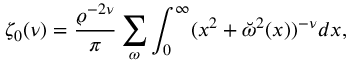<formula> <loc_0><loc_0><loc_500><loc_500>\zeta _ { 0 } ( \nu ) = { \frac { \varrho ^ { - 2 \nu } } { \pi } } \sum _ { \omega } \int _ { 0 } ^ { \infty } ( x ^ { 2 } + \breve { \omega } ^ { 2 } ( x ) ) ^ { - \nu } d x ,</formula> 